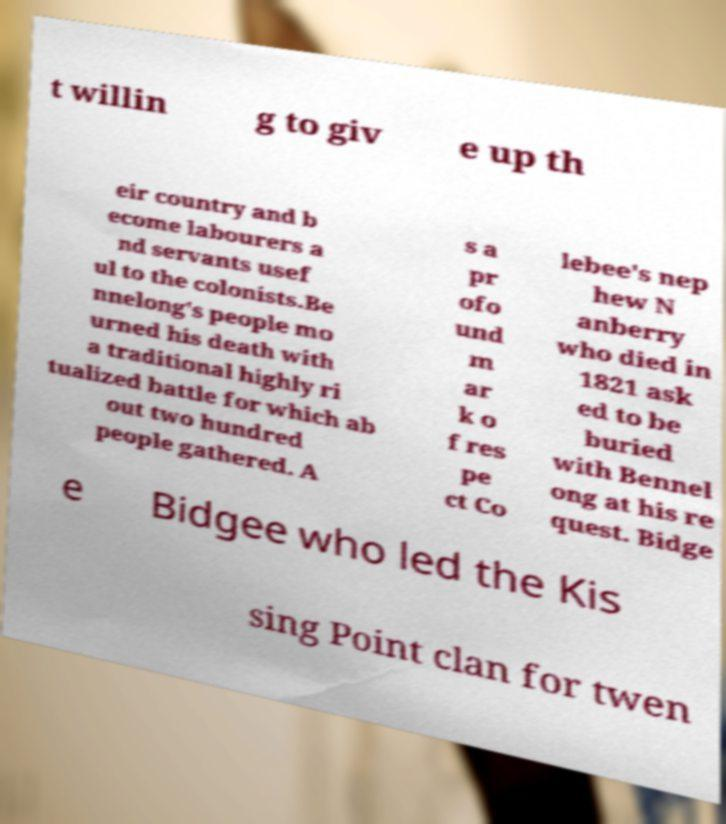I need the written content from this picture converted into text. Can you do that? t willin g to giv e up th eir country and b ecome labourers a nd servants usef ul to the colonists.Be nnelong's people mo urned his death with a traditional highly ri tualized battle for which ab out two hundred people gathered. A s a pr ofo und m ar k o f res pe ct Co lebee's nep hew N anberry who died in 1821 ask ed to be buried with Bennel ong at his re quest. Bidge e Bidgee who led the Kis sing Point clan for twen 